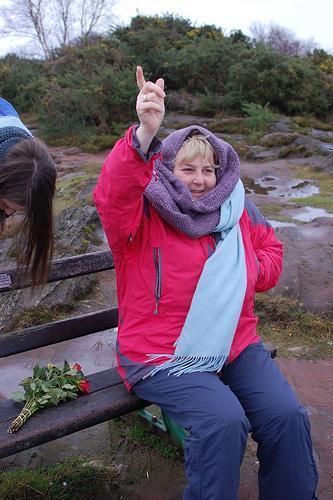How many people are there?
Give a very brief answer. 2. 